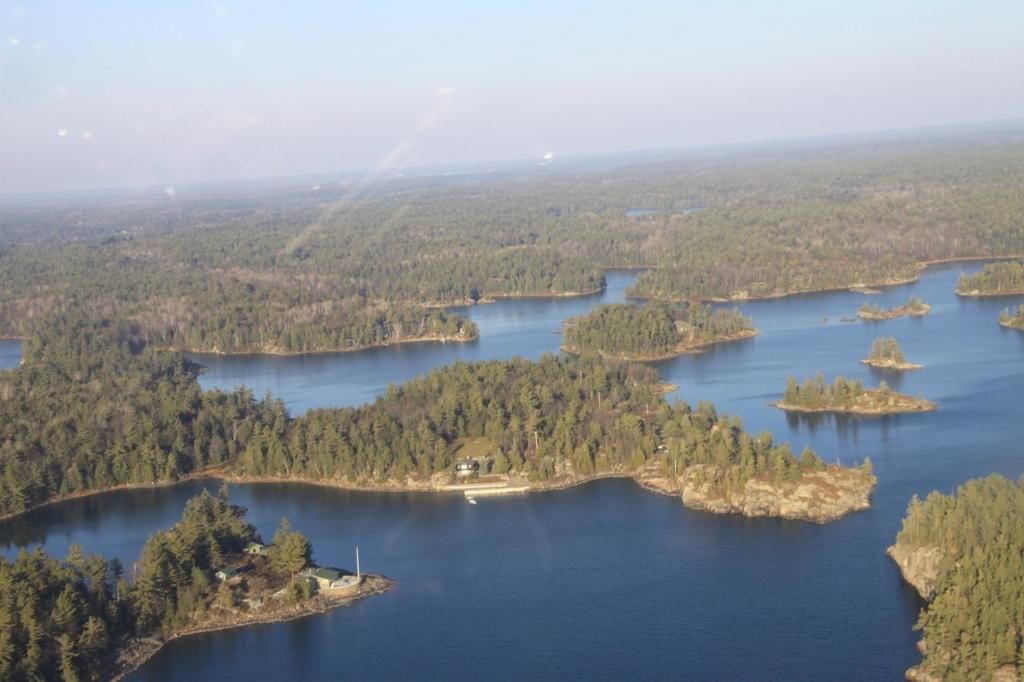What perspective is used to capture the image? The image is taken from a top view. What types of terrain can be seen in the image? There is land and water visible in the image. What vegetation is present on the land? There are trees on the land. What is visible in the background of the image? The sky is visible in the image. Can you see a tray floating on the water in the image? There is no tray visible in the image; it only features land, water, trees, and the sky. 